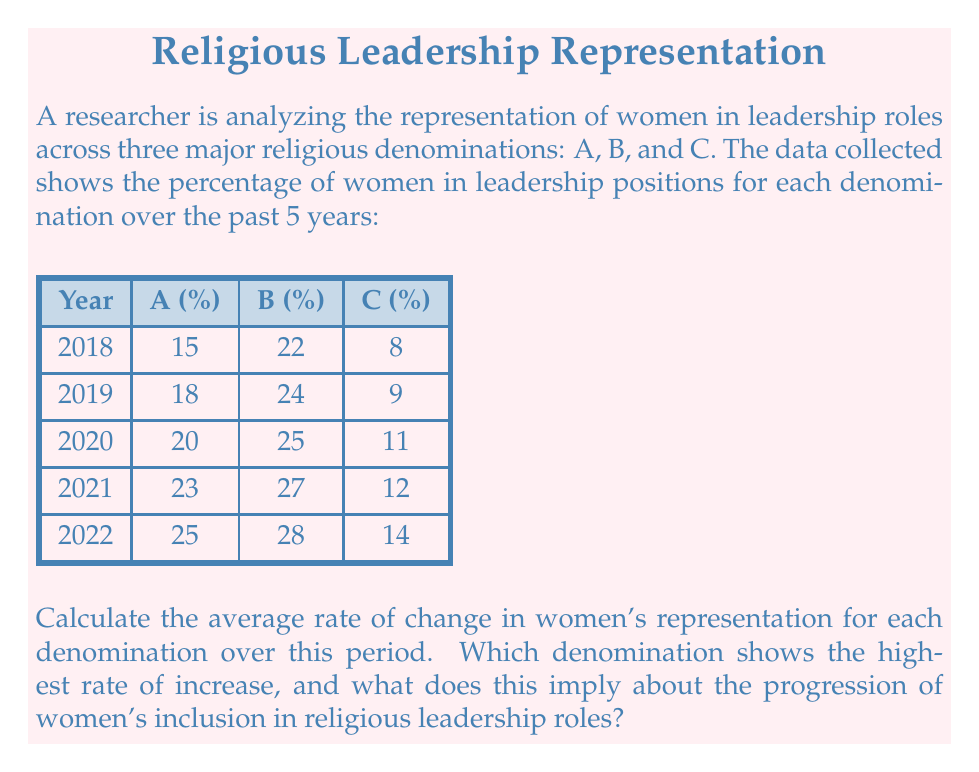Can you answer this question? To solve this problem, we need to calculate the average rate of change for each denomination:

1. Calculate the total change for each denomination:
   A: $25\% - 15\% = 10\%$
   B: $28\% - 22\% = 6\%$
   C: $14\% - 8\% = 6\%$

2. Calculate the average rate of change per year:
   Average rate of change = $\frac{\text{Total change}}{\text{Number of years}}$

   For denomination A: $\frac{10\%}{4} = 2.5\%$ per year
   For denomination B: $\frac{6\%}{4} = 1.5\%$ per year
   For denomination C: $\frac{6\%}{4} = 1.5\%$ per year

3. Compare the rates:
   Denomination A has the highest rate of increase at 2.5% per year.

This implies that denomination A is making the most rapid progress in increasing women's representation in leadership roles. While it started with a lower percentage than B, its faster rate of change suggests a more active effort to include women in religious leadership. However, it's important to note that despite the higher rate of change, denomination B still maintains the highest overall percentage of women in leadership roles throughout the period.
Answer: Denomination A: 2.5% per year 